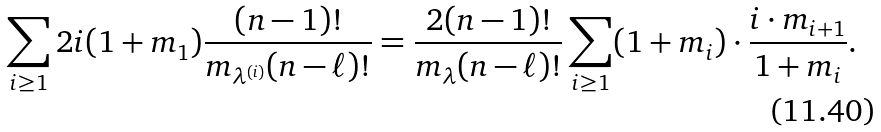<formula> <loc_0><loc_0><loc_500><loc_500>\sum _ { i \geq 1 } 2 i ( 1 + m _ { 1 } ) \frac { ( n - 1 ) ! } { m _ { \lambda ^ { ( i ) } } ( n - \ell ) ! } = \frac { 2 ( n - 1 ) ! } { m _ { \lambda } ( n - \ell ) ! } \sum _ { i \geq 1 } ( 1 + m _ { i } ) \cdot \frac { i \cdot m _ { i + 1 } } { 1 + m _ { i } } .</formula> 